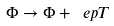<formula> <loc_0><loc_0><loc_500><loc_500>\Phi \to \Phi + \ e p T</formula> 